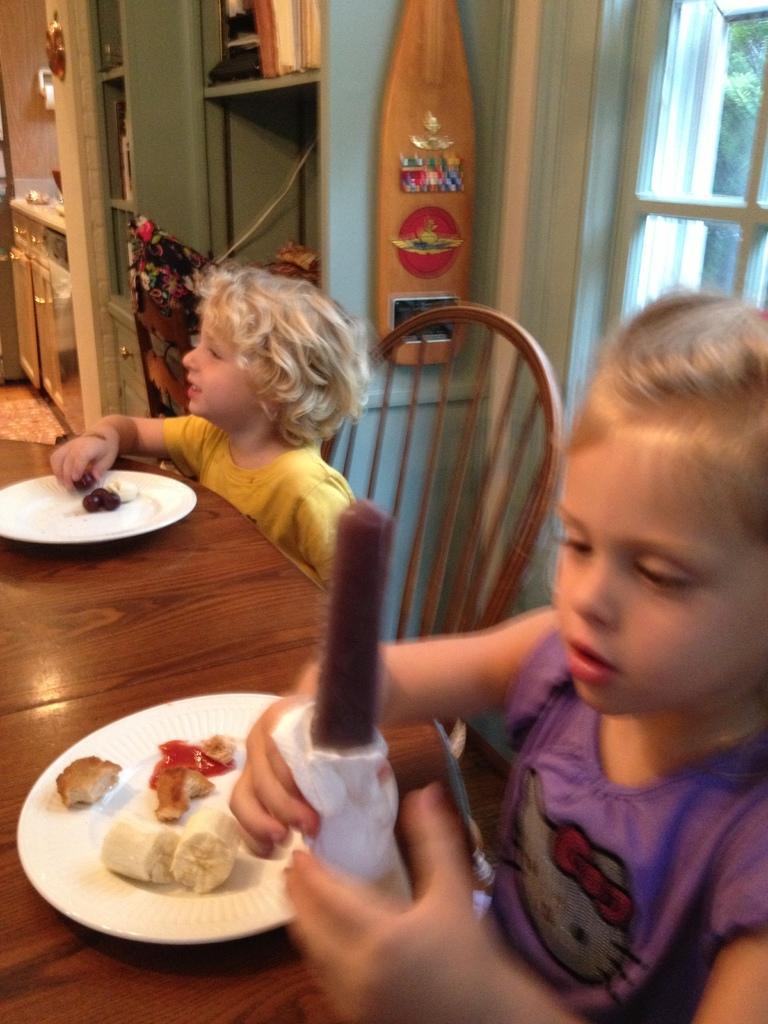Can you describe this image briefly? In this image I see 2 children who are sitting on chairs and there is a table in front of them on which there are 2 plates and food on it, I can also see these 2 are holding some food in their hands, In the background I see the racks and a window over here. 